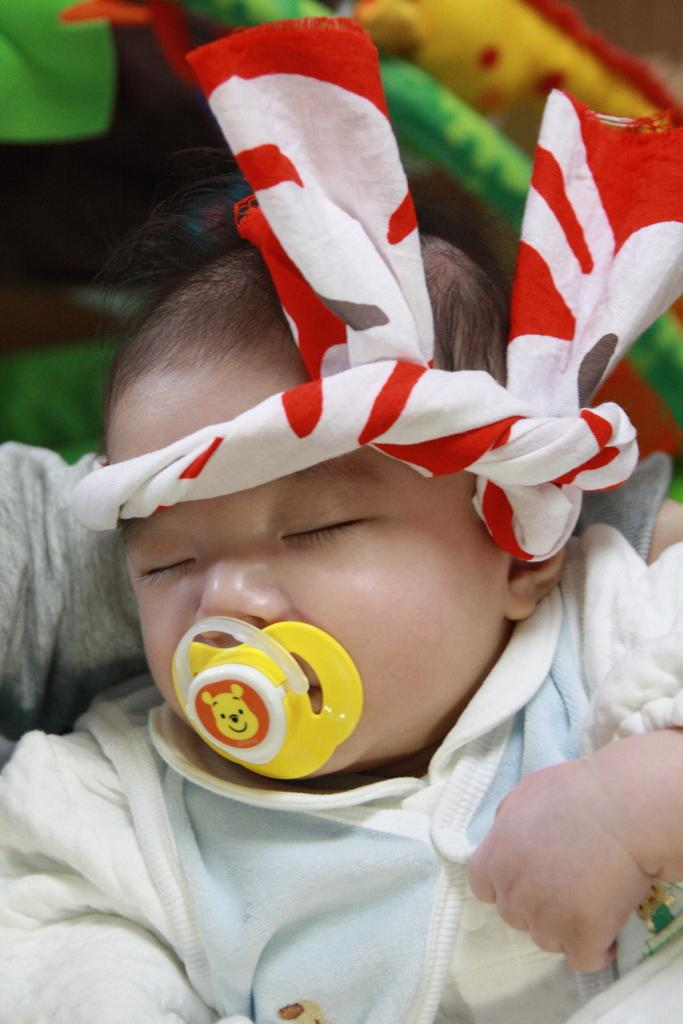Where was the image taken? The image was taken indoors. What can be seen in the background of the image? There is a baby carrier in the background of the image. What is the main subject of the image? There is a baby in the middle of the image. What type of loaf is the farmer holding in the image? There is no farmer or loaf present in the image. 